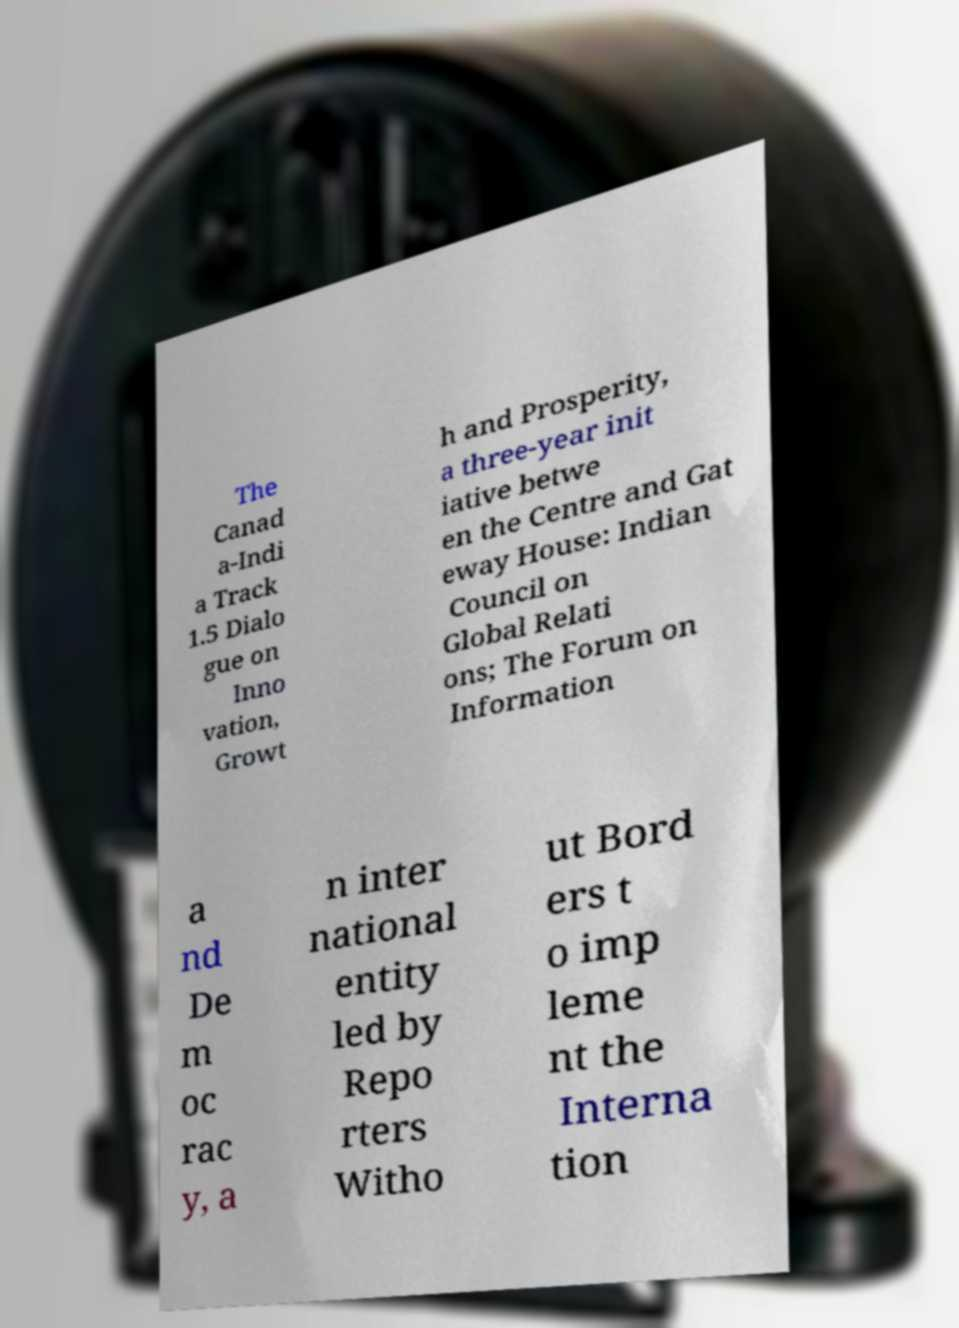Please identify and transcribe the text found in this image. The Canad a-Indi a Track 1.5 Dialo gue on Inno vation, Growt h and Prosperity, a three-year init iative betwe en the Centre and Gat eway House: Indian Council on Global Relati ons; The Forum on Information a nd De m oc rac y, a n inter national entity led by Repo rters Witho ut Bord ers t o imp leme nt the Interna tion 